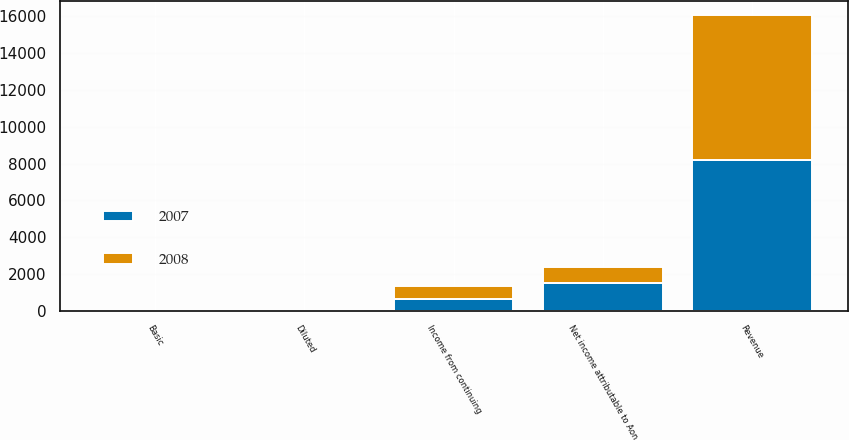Convert chart. <chart><loc_0><loc_0><loc_500><loc_500><stacked_bar_chart><ecel><fcel>Revenue<fcel>Income from continuing<fcel>Net income attributable to Aon<fcel>Basic<fcel>Diluted<nl><fcel>2007<fcel>8180<fcel>646<fcel>1487<fcel>5.08<fcel>4.88<nl><fcel>2008<fcel>7869<fcel>712<fcel>914<fcel>3<fcel>2.81<nl></chart> 